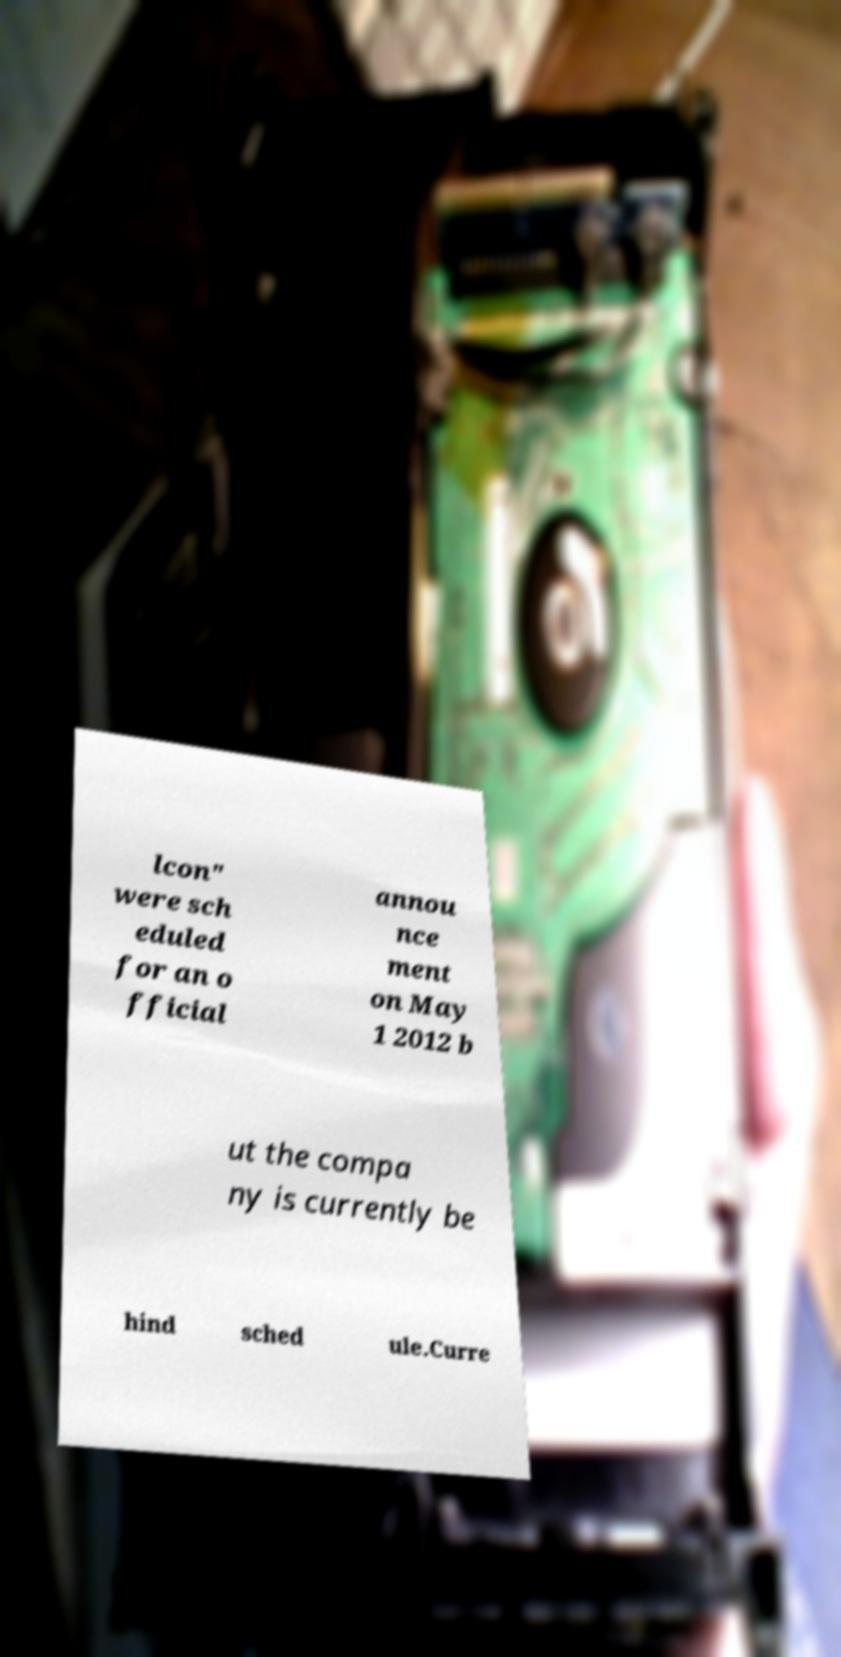There's text embedded in this image that I need extracted. Can you transcribe it verbatim? lcon" were sch eduled for an o fficial annou nce ment on May 1 2012 b ut the compa ny is currently be hind sched ule.Curre 